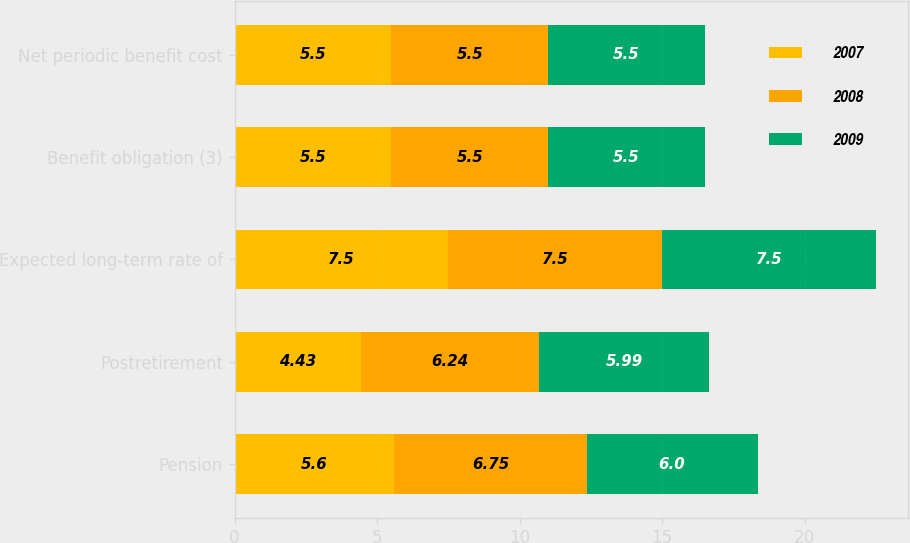Convert chart to OTSL. <chart><loc_0><loc_0><loc_500><loc_500><stacked_bar_chart><ecel><fcel>Pension<fcel>Postretirement<fcel>Expected long-term rate of<fcel>Benefit obligation (3)<fcel>Net periodic benefit cost<nl><fcel>2007<fcel>5.6<fcel>4.43<fcel>7.5<fcel>5.5<fcel>5.5<nl><fcel>2008<fcel>6.75<fcel>6.24<fcel>7.5<fcel>5.5<fcel>5.5<nl><fcel>2009<fcel>6<fcel>5.99<fcel>7.5<fcel>5.5<fcel>5.5<nl></chart> 